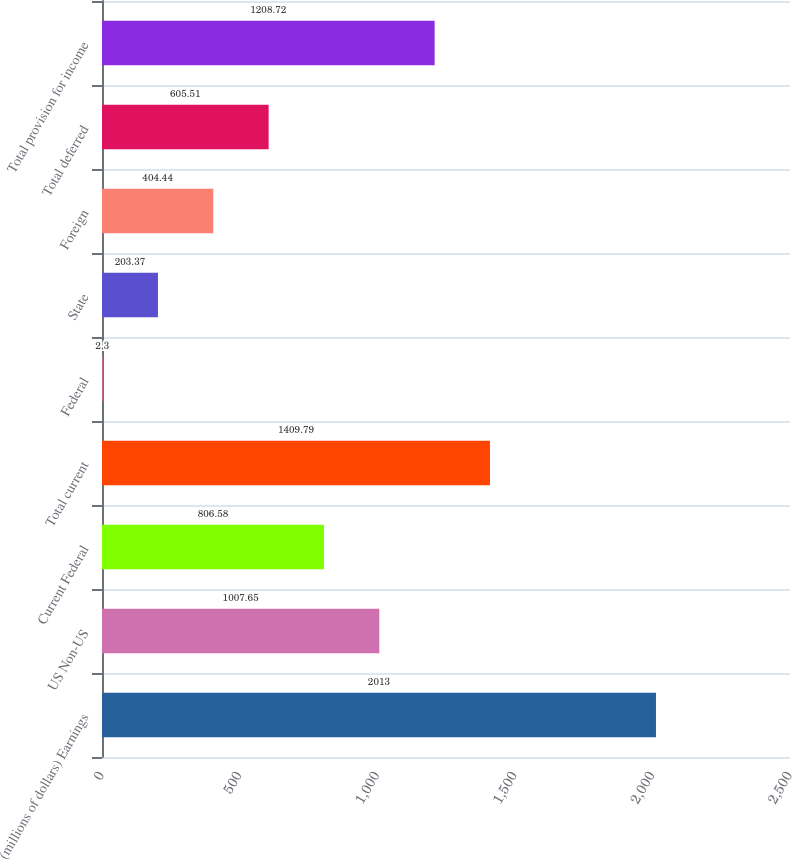Convert chart. <chart><loc_0><loc_0><loc_500><loc_500><bar_chart><fcel>(millions of dollars) Earnings<fcel>US Non-US<fcel>Current Federal<fcel>Total current<fcel>Federal<fcel>State<fcel>Foreign<fcel>Total deferred<fcel>Total provision for income<nl><fcel>2013<fcel>1007.65<fcel>806.58<fcel>1409.79<fcel>2.3<fcel>203.37<fcel>404.44<fcel>605.51<fcel>1208.72<nl></chart> 